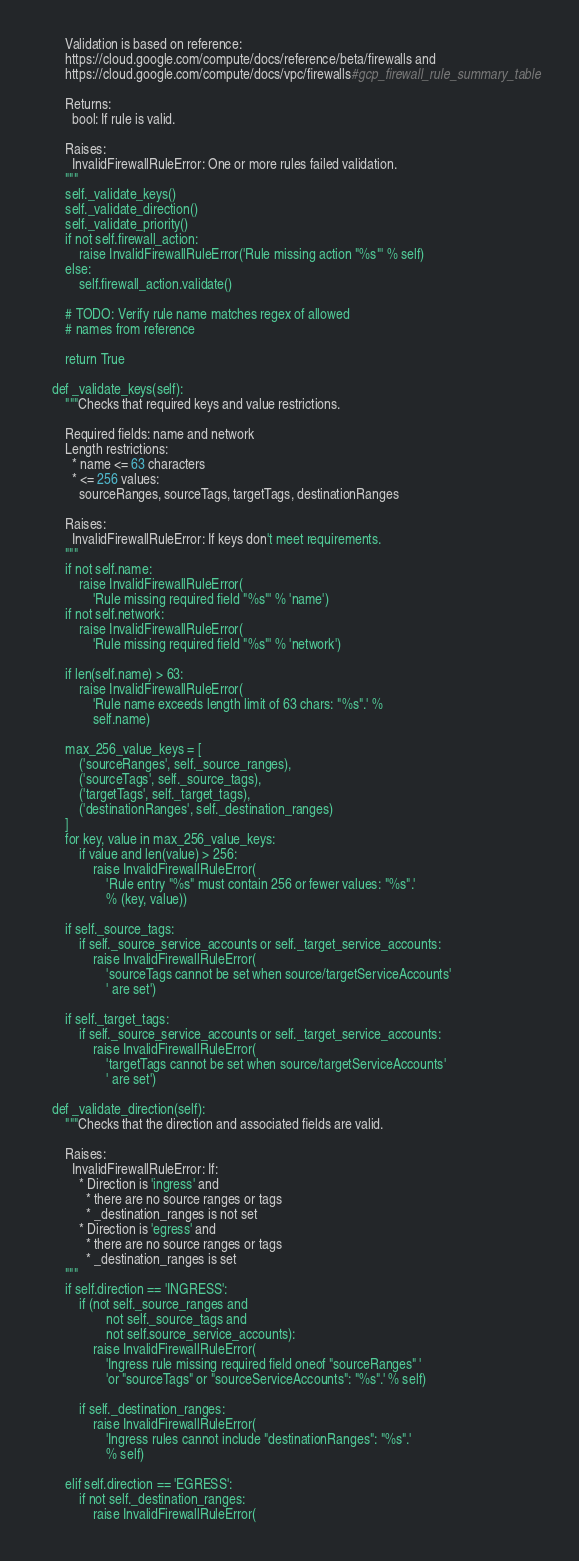<code> <loc_0><loc_0><loc_500><loc_500><_Python_>
        Validation is based on reference:
        https://cloud.google.com/compute/docs/reference/beta/firewalls and
        https://cloud.google.com/compute/docs/vpc/firewalls#gcp_firewall_rule_summary_table

        Returns:
          bool: If rule is valid.

        Raises:
          InvalidFirewallRuleError: One or more rules failed validation.
        """
        self._validate_keys()
        self._validate_direction()
        self._validate_priority()
        if not self.firewall_action:
            raise InvalidFirewallRuleError('Rule missing action "%s"' % self)
        else:
            self.firewall_action.validate()

        # TODO: Verify rule name matches regex of allowed
        # names from reference

        return True

    def _validate_keys(self):
        """Checks that required keys and value restrictions.

        Required fields: name and network
        Length restrictions:
          * name <= 63 characters
          * <= 256 values:
            sourceRanges, sourceTags, targetTags, destinationRanges

        Raises:
          InvalidFirewallRuleError: If keys don't meet requirements.
        """
        if not self.name:
            raise InvalidFirewallRuleError(
                'Rule missing required field "%s"' % 'name')
        if not self.network:
            raise InvalidFirewallRuleError(
                'Rule missing required field "%s"' % 'network')

        if len(self.name) > 63:
            raise InvalidFirewallRuleError(
                'Rule name exceeds length limit of 63 chars: "%s".' %
                self.name)

        max_256_value_keys = [
            ('sourceRanges', self._source_ranges),
            ('sourceTags', self._source_tags),
            ('targetTags', self._target_tags),
            ('destinationRanges', self._destination_ranges)
        ]
        for key, value in max_256_value_keys:
            if value and len(value) > 256:
                raise InvalidFirewallRuleError(
                    'Rule entry "%s" must contain 256 or fewer values: "%s".'
                    % (key, value))

        if self._source_tags:
            if self._source_service_accounts or self._target_service_accounts:
                raise InvalidFirewallRuleError(
                    'sourceTags cannot be set when source/targetServiceAccounts'
                    ' are set')

        if self._target_tags:
            if self._source_service_accounts or self._target_service_accounts:
                raise InvalidFirewallRuleError(
                    'targetTags cannot be set when source/targetServiceAccounts'
                    ' are set')

    def _validate_direction(self):
        """Checks that the direction and associated fields are valid.

        Raises:
          InvalidFirewallRuleError: If:
            * Direction is 'ingress' and
              * there are no source ranges or tags
              * _destination_ranges is not set
            * Direction is 'egress' and
              * there are no source ranges or tags
              * _destination_ranges is set
        """
        if self.direction == 'INGRESS':
            if (not self._source_ranges and
                    not self._source_tags and
                    not self.source_service_accounts):
                raise InvalidFirewallRuleError(
                    'Ingress rule missing required field oneof "sourceRanges" '
                    'or "sourceTags" or "sourceServiceAccounts": "%s".' % self)

            if self._destination_ranges:
                raise InvalidFirewallRuleError(
                    'Ingress rules cannot include "destinationRanges": "%s".'
                    % self)

        elif self.direction == 'EGRESS':
            if not self._destination_ranges:
                raise InvalidFirewallRuleError(</code> 